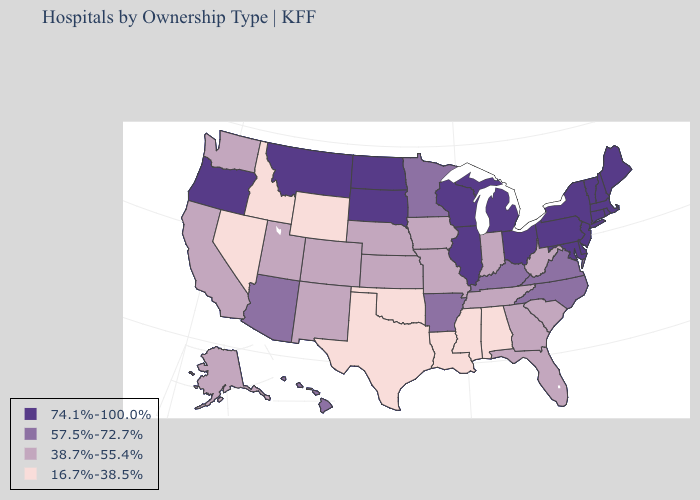Does Ohio have a higher value than Hawaii?
Give a very brief answer. Yes. Name the states that have a value in the range 74.1%-100.0%?
Short answer required. Connecticut, Delaware, Illinois, Maine, Maryland, Massachusetts, Michigan, Montana, New Hampshire, New Jersey, New York, North Dakota, Ohio, Oregon, Pennsylvania, Rhode Island, South Dakota, Vermont, Wisconsin. Does the map have missing data?
Write a very short answer. No. Does the map have missing data?
Answer briefly. No. What is the highest value in the USA?
Quick response, please. 74.1%-100.0%. What is the value of Tennessee?
Answer briefly. 38.7%-55.4%. What is the value of Oklahoma?
Quick response, please. 16.7%-38.5%. Which states have the highest value in the USA?
Be succinct. Connecticut, Delaware, Illinois, Maine, Maryland, Massachusetts, Michigan, Montana, New Hampshire, New Jersey, New York, North Dakota, Ohio, Oregon, Pennsylvania, Rhode Island, South Dakota, Vermont, Wisconsin. What is the highest value in states that border Delaware?
Answer briefly. 74.1%-100.0%. What is the lowest value in states that border Connecticut?
Give a very brief answer. 74.1%-100.0%. What is the lowest value in states that border New Jersey?
Write a very short answer. 74.1%-100.0%. Name the states that have a value in the range 16.7%-38.5%?
Concise answer only. Alabama, Idaho, Louisiana, Mississippi, Nevada, Oklahoma, Texas, Wyoming. What is the lowest value in the MidWest?
Write a very short answer. 38.7%-55.4%. Which states hav the highest value in the MidWest?
Give a very brief answer. Illinois, Michigan, North Dakota, Ohio, South Dakota, Wisconsin. What is the lowest value in the USA?
Answer briefly. 16.7%-38.5%. 